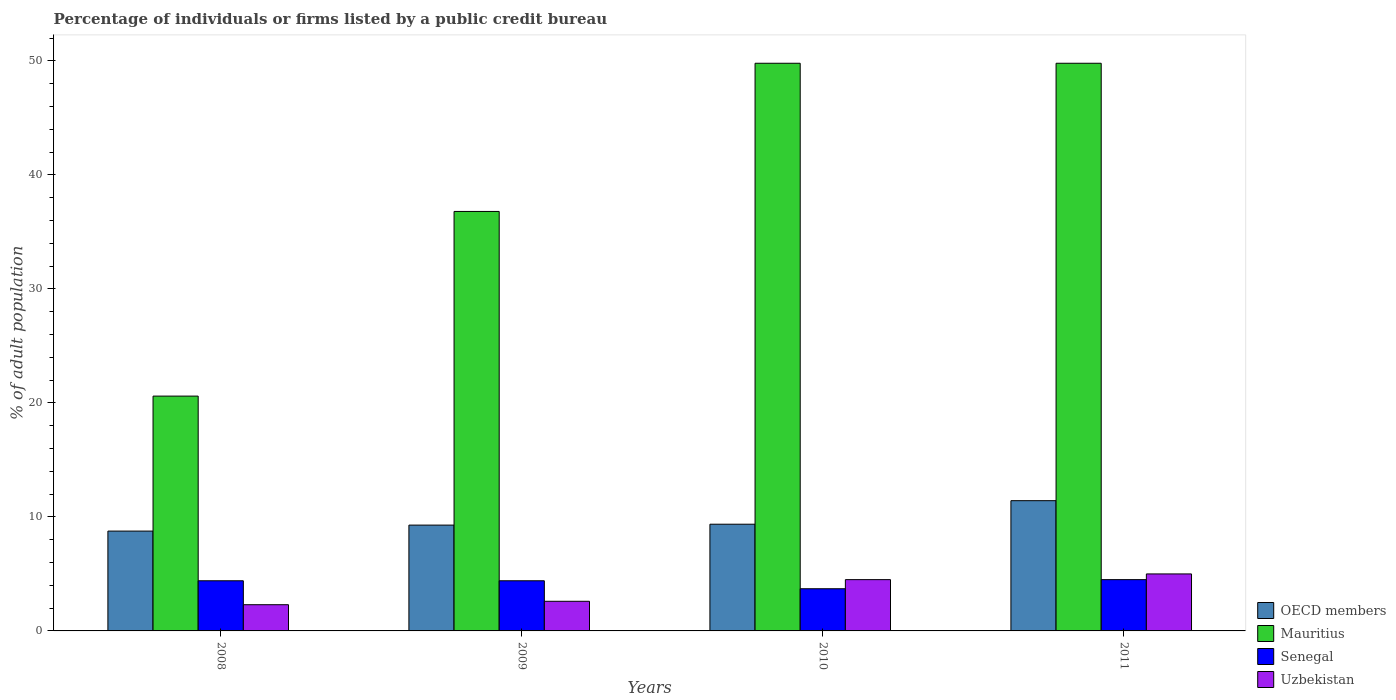Are the number of bars per tick equal to the number of legend labels?
Provide a succinct answer. Yes. How many bars are there on the 3rd tick from the left?
Make the answer very short. 4. What is the percentage of population listed by a public credit bureau in OECD members in 2010?
Provide a succinct answer. 9.36. Across all years, what is the maximum percentage of population listed by a public credit bureau in OECD members?
Your response must be concise. 11.43. Across all years, what is the minimum percentage of population listed by a public credit bureau in Senegal?
Your response must be concise. 3.7. What is the total percentage of population listed by a public credit bureau in Mauritius in the graph?
Make the answer very short. 157. What is the difference between the percentage of population listed by a public credit bureau in OECD members in 2009 and that in 2010?
Keep it short and to the point. -0.08. What is the difference between the percentage of population listed by a public credit bureau in Mauritius in 2010 and the percentage of population listed by a public credit bureau in OECD members in 2009?
Ensure brevity in your answer.  40.52. What is the average percentage of population listed by a public credit bureau in OECD members per year?
Your answer should be very brief. 9.71. In the year 2010, what is the difference between the percentage of population listed by a public credit bureau in OECD members and percentage of population listed by a public credit bureau in Mauritius?
Offer a very short reply. -40.44. Is the percentage of population listed by a public credit bureau in OECD members in 2008 less than that in 2011?
Your answer should be very brief. Yes. What is the difference between the highest and the second highest percentage of population listed by a public credit bureau in Senegal?
Ensure brevity in your answer.  0.1. What is the difference between the highest and the lowest percentage of population listed by a public credit bureau in Mauritius?
Keep it short and to the point. 29.2. Is the sum of the percentage of population listed by a public credit bureau in Uzbekistan in 2008 and 2011 greater than the maximum percentage of population listed by a public credit bureau in Mauritius across all years?
Give a very brief answer. No. Is it the case that in every year, the sum of the percentage of population listed by a public credit bureau in Uzbekistan and percentage of population listed by a public credit bureau in OECD members is greater than the sum of percentage of population listed by a public credit bureau in Senegal and percentage of population listed by a public credit bureau in Mauritius?
Provide a short and direct response. No. Are all the bars in the graph horizontal?
Your answer should be compact. No. What is the difference between two consecutive major ticks on the Y-axis?
Provide a short and direct response. 10. Are the values on the major ticks of Y-axis written in scientific E-notation?
Offer a terse response. No. Does the graph contain any zero values?
Keep it short and to the point. No. How are the legend labels stacked?
Ensure brevity in your answer.  Vertical. What is the title of the graph?
Make the answer very short. Percentage of individuals or firms listed by a public credit bureau. What is the label or title of the Y-axis?
Offer a terse response. % of adult population. What is the % of adult population in OECD members in 2008?
Provide a succinct answer. 8.76. What is the % of adult population in Mauritius in 2008?
Make the answer very short. 20.6. What is the % of adult population of Senegal in 2008?
Ensure brevity in your answer.  4.4. What is the % of adult population in Uzbekistan in 2008?
Provide a succinct answer. 2.3. What is the % of adult population of OECD members in 2009?
Make the answer very short. 9.28. What is the % of adult population of Mauritius in 2009?
Your answer should be very brief. 36.8. What is the % of adult population in OECD members in 2010?
Your response must be concise. 9.36. What is the % of adult population in Mauritius in 2010?
Offer a very short reply. 49.8. What is the % of adult population in Senegal in 2010?
Provide a succinct answer. 3.7. What is the % of adult population of OECD members in 2011?
Ensure brevity in your answer.  11.43. What is the % of adult population in Mauritius in 2011?
Offer a terse response. 49.8. What is the % of adult population of Senegal in 2011?
Provide a succinct answer. 4.5. What is the % of adult population of Uzbekistan in 2011?
Keep it short and to the point. 5. Across all years, what is the maximum % of adult population in OECD members?
Keep it short and to the point. 11.43. Across all years, what is the maximum % of adult population of Mauritius?
Ensure brevity in your answer.  49.8. Across all years, what is the minimum % of adult population in OECD members?
Keep it short and to the point. 8.76. Across all years, what is the minimum % of adult population of Mauritius?
Offer a very short reply. 20.6. What is the total % of adult population of OECD members in the graph?
Provide a short and direct response. 38.83. What is the total % of adult population in Mauritius in the graph?
Ensure brevity in your answer.  157. What is the total % of adult population of Uzbekistan in the graph?
Your answer should be very brief. 14.4. What is the difference between the % of adult population of OECD members in 2008 and that in 2009?
Provide a succinct answer. -0.53. What is the difference between the % of adult population in Mauritius in 2008 and that in 2009?
Keep it short and to the point. -16.2. What is the difference between the % of adult population of OECD members in 2008 and that in 2010?
Provide a short and direct response. -0.6. What is the difference between the % of adult population in Mauritius in 2008 and that in 2010?
Give a very brief answer. -29.2. What is the difference between the % of adult population of Senegal in 2008 and that in 2010?
Offer a terse response. 0.7. What is the difference between the % of adult population of OECD members in 2008 and that in 2011?
Ensure brevity in your answer.  -2.67. What is the difference between the % of adult population of Mauritius in 2008 and that in 2011?
Provide a short and direct response. -29.2. What is the difference between the % of adult population of Senegal in 2008 and that in 2011?
Make the answer very short. -0.1. What is the difference between the % of adult population of Uzbekistan in 2008 and that in 2011?
Your response must be concise. -2.7. What is the difference between the % of adult population in OECD members in 2009 and that in 2010?
Your answer should be very brief. -0.08. What is the difference between the % of adult population of Senegal in 2009 and that in 2010?
Keep it short and to the point. 0.7. What is the difference between the % of adult population in OECD members in 2009 and that in 2011?
Offer a very short reply. -2.14. What is the difference between the % of adult population in OECD members in 2010 and that in 2011?
Provide a short and direct response. -2.06. What is the difference between the % of adult population in Uzbekistan in 2010 and that in 2011?
Provide a succinct answer. -0.5. What is the difference between the % of adult population in OECD members in 2008 and the % of adult population in Mauritius in 2009?
Keep it short and to the point. -28.04. What is the difference between the % of adult population in OECD members in 2008 and the % of adult population in Senegal in 2009?
Provide a succinct answer. 4.36. What is the difference between the % of adult population of OECD members in 2008 and the % of adult population of Uzbekistan in 2009?
Your response must be concise. 6.16. What is the difference between the % of adult population in Mauritius in 2008 and the % of adult population in Senegal in 2009?
Ensure brevity in your answer.  16.2. What is the difference between the % of adult population in Senegal in 2008 and the % of adult population in Uzbekistan in 2009?
Give a very brief answer. 1.8. What is the difference between the % of adult population in OECD members in 2008 and the % of adult population in Mauritius in 2010?
Offer a very short reply. -41.04. What is the difference between the % of adult population of OECD members in 2008 and the % of adult population of Senegal in 2010?
Ensure brevity in your answer.  5.06. What is the difference between the % of adult population of OECD members in 2008 and the % of adult population of Uzbekistan in 2010?
Make the answer very short. 4.26. What is the difference between the % of adult population in Mauritius in 2008 and the % of adult population in Uzbekistan in 2010?
Provide a succinct answer. 16.1. What is the difference between the % of adult population in OECD members in 2008 and the % of adult population in Mauritius in 2011?
Keep it short and to the point. -41.04. What is the difference between the % of adult population in OECD members in 2008 and the % of adult population in Senegal in 2011?
Provide a short and direct response. 4.26. What is the difference between the % of adult population of OECD members in 2008 and the % of adult population of Uzbekistan in 2011?
Your answer should be compact. 3.76. What is the difference between the % of adult population in Mauritius in 2008 and the % of adult population in Senegal in 2011?
Make the answer very short. 16.1. What is the difference between the % of adult population in Senegal in 2008 and the % of adult population in Uzbekistan in 2011?
Ensure brevity in your answer.  -0.6. What is the difference between the % of adult population of OECD members in 2009 and the % of adult population of Mauritius in 2010?
Offer a very short reply. -40.52. What is the difference between the % of adult population of OECD members in 2009 and the % of adult population of Senegal in 2010?
Make the answer very short. 5.58. What is the difference between the % of adult population of OECD members in 2009 and the % of adult population of Uzbekistan in 2010?
Provide a succinct answer. 4.78. What is the difference between the % of adult population of Mauritius in 2009 and the % of adult population of Senegal in 2010?
Offer a terse response. 33.1. What is the difference between the % of adult population of Mauritius in 2009 and the % of adult population of Uzbekistan in 2010?
Provide a succinct answer. 32.3. What is the difference between the % of adult population in OECD members in 2009 and the % of adult population in Mauritius in 2011?
Make the answer very short. -40.52. What is the difference between the % of adult population in OECD members in 2009 and the % of adult population in Senegal in 2011?
Offer a very short reply. 4.78. What is the difference between the % of adult population in OECD members in 2009 and the % of adult population in Uzbekistan in 2011?
Keep it short and to the point. 4.28. What is the difference between the % of adult population in Mauritius in 2009 and the % of adult population in Senegal in 2011?
Keep it short and to the point. 32.3. What is the difference between the % of adult population in Mauritius in 2009 and the % of adult population in Uzbekistan in 2011?
Provide a succinct answer. 31.8. What is the difference between the % of adult population of OECD members in 2010 and the % of adult population of Mauritius in 2011?
Your answer should be very brief. -40.44. What is the difference between the % of adult population of OECD members in 2010 and the % of adult population of Senegal in 2011?
Your answer should be very brief. 4.86. What is the difference between the % of adult population in OECD members in 2010 and the % of adult population in Uzbekistan in 2011?
Provide a succinct answer. 4.36. What is the difference between the % of adult population in Mauritius in 2010 and the % of adult population in Senegal in 2011?
Your response must be concise. 45.3. What is the difference between the % of adult population of Mauritius in 2010 and the % of adult population of Uzbekistan in 2011?
Make the answer very short. 44.8. What is the difference between the % of adult population in Senegal in 2010 and the % of adult population in Uzbekistan in 2011?
Give a very brief answer. -1.3. What is the average % of adult population of OECD members per year?
Ensure brevity in your answer.  9.71. What is the average % of adult population in Mauritius per year?
Offer a very short reply. 39.25. What is the average % of adult population of Senegal per year?
Your answer should be compact. 4.25. What is the average % of adult population in Uzbekistan per year?
Your answer should be compact. 3.6. In the year 2008, what is the difference between the % of adult population in OECD members and % of adult population in Mauritius?
Ensure brevity in your answer.  -11.84. In the year 2008, what is the difference between the % of adult population in OECD members and % of adult population in Senegal?
Ensure brevity in your answer.  4.36. In the year 2008, what is the difference between the % of adult population in OECD members and % of adult population in Uzbekistan?
Provide a succinct answer. 6.46. In the year 2008, what is the difference between the % of adult population in Mauritius and % of adult population in Senegal?
Offer a terse response. 16.2. In the year 2008, what is the difference between the % of adult population in Senegal and % of adult population in Uzbekistan?
Offer a very short reply. 2.1. In the year 2009, what is the difference between the % of adult population in OECD members and % of adult population in Mauritius?
Your response must be concise. -27.52. In the year 2009, what is the difference between the % of adult population in OECD members and % of adult population in Senegal?
Ensure brevity in your answer.  4.88. In the year 2009, what is the difference between the % of adult population in OECD members and % of adult population in Uzbekistan?
Your response must be concise. 6.68. In the year 2009, what is the difference between the % of adult population in Mauritius and % of adult population in Senegal?
Your response must be concise. 32.4. In the year 2009, what is the difference between the % of adult population of Mauritius and % of adult population of Uzbekistan?
Give a very brief answer. 34.2. In the year 2010, what is the difference between the % of adult population in OECD members and % of adult population in Mauritius?
Ensure brevity in your answer.  -40.44. In the year 2010, what is the difference between the % of adult population in OECD members and % of adult population in Senegal?
Your answer should be compact. 5.66. In the year 2010, what is the difference between the % of adult population of OECD members and % of adult population of Uzbekistan?
Your answer should be very brief. 4.86. In the year 2010, what is the difference between the % of adult population of Mauritius and % of adult population of Senegal?
Provide a short and direct response. 46.1. In the year 2010, what is the difference between the % of adult population of Mauritius and % of adult population of Uzbekistan?
Your answer should be very brief. 45.3. In the year 2010, what is the difference between the % of adult population of Senegal and % of adult population of Uzbekistan?
Provide a short and direct response. -0.8. In the year 2011, what is the difference between the % of adult population in OECD members and % of adult population in Mauritius?
Your response must be concise. -38.37. In the year 2011, what is the difference between the % of adult population of OECD members and % of adult population of Senegal?
Give a very brief answer. 6.93. In the year 2011, what is the difference between the % of adult population of OECD members and % of adult population of Uzbekistan?
Provide a succinct answer. 6.43. In the year 2011, what is the difference between the % of adult population of Mauritius and % of adult population of Senegal?
Ensure brevity in your answer.  45.3. In the year 2011, what is the difference between the % of adult population of Mauritius and % of adult population of Uzbekistan?
Ensure brevity in your answer.  44.8. In the year 2011, what is the difference between the % of adult population of Senegal and % of adult population of Uzbekistan?
Provide a succinct answer. -0.5. What is the ratio of the % of adult population in OECD members in 2008 to that in 2009?
Your response must be concise. 0.94. What is the ratio of the % of adult population of Mauritius in 2008 to that in 2009?
Provide a succinct answer. 0.56. What is the ratio of the % of adult population in Uzbekistan in 2008 to that in 2009?
Ensure brevity in your answer.  0.88. What is the ratio of the % of adult population in OECD members in 2008 to that in 2010?
Give a very brief answer. 0.94. What is the ratio of the % of adult population of Mauritius in 2008 to that in 2010?
Your response must be concise. 0.41. What is the ratio of the % of adult population in Senegal in 2008 to that in 2010?
Give a very brief answer. 1.19. What is the ratio of the % of adult population in Uzbekistan in 2008 to that in 2010?
Offer a terse response. 0.51. What is the ratio of the % of adult population in OECD members in 2008 to that in 2011?
Offer a terse response. 0.77. What is the ratio of the % of adult population in Mauritius in 2008 to that in 2011?
Ensure brevity in your answer.  0.41. What is the ratio of the % of adult population of Senegal in 2008 to that in 2011?
Ensure brevity in your answer.  0.98. What is the ratio of the % of adult population in Uzbekistan in 2008 to that in 2011?
Your answer should be compact. 0.46. What is the ratio of the % of adult population of Mauritius in 2009 to that in 2010?
Provide a short and direct response. 0.74. What is the ratio of the % of adult population of Senegal in 2009 to that in 2010?
Offer a terse response. 1.19. What is the ratio of the % of adult population of Uzbekistan in 2009 to that in 2010?
Make the answer very short. 0.58. What is the ratio of the % of adult population in OECD members in 2009 to that in 2011?
Your answer should be compact. 0.81. What is the ratio of the % of adult population of Mauritius in 2009 to that in 2011?
Your response must be concise. 0.74. What is the ratio of the % of adult population in Senegal in 2009 to that in 2011?
Your answer should be very brief. 0.98. What is the ratio of the % of adult population in Uzbekistan in 2009 to that in 2011?
Your answer should be very brief. 0.52. What is the ratio of the % of adult population in OECD members in 2010 to that in 2011?
Offer a very short reply. 0.82. What is the ratio of the % of adult population in Mauritius in 2010 to that in 2011?
Offer a terse response. 1. What is the ratio of the % of adult population in Senegal in 2010 to that in 2011?
Make the answer very short. 0.82. What is the ratio of the % of adult population in Uzbekistan in 2010 to that in 2011?
Offer a terse response. 0.9. What is the difference between the highest and the second highest % of adult population of OECD members?
Your answer should be very brief. 2.06. What is the difference between the highest and the second highest % of adult population in Senegal?
Provide a short and direct response. 0.1. What is the difference between the highest and the second highest % of adult population in Uzbekistan?
Provide a short and direct response. 0.5. What is the difference between the highest and the lowest % of adult population of OECD members?
Provide a succinct answer. 2.67. What is the difference between the highest and the lowest % of adult population in Mauritius?
Offer a terse response. 29.2. What is the difference between the highest and the lowest % of adult population of Senegal?
Ensure brevity in your answer.  0.8. 